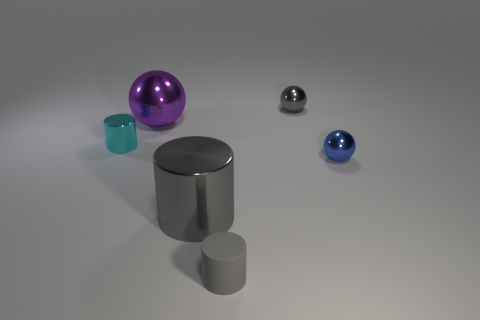This scene feels very minimalist; could it represent anything specific, maybe something conceptual or philosophical? While the scene is open to interpretation, one might view it as a visualization of order and chaos, with the objects neatly arranged yet varying in shape, size, and color, indicating diversity. Alternatively, it could represent the idea of individuality and unity – each object is distinct, but they collectively create a balanced and harmonious arrangement.  How do the lighting and shadows contribute to the overall mood of the image? The lighting is soft and diffused, creating gentle shadows that lend the scene a serene and almost contemplative quality. The play of light highlights the textures and materials of the objects, enhancing the visual appeal and depth of the composition. 